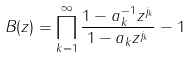<formula> <loc_0><loc_0><loc_500><loc_500>B ( z ) = \prod _ { k = 1 } ^ { \infty } \frac { 1 - a _ { k } ^ { - 1 } z ^ { j _ { k } } } { 1 - a _ { k } z ^ { j _ { k } } } - 1</formula> 